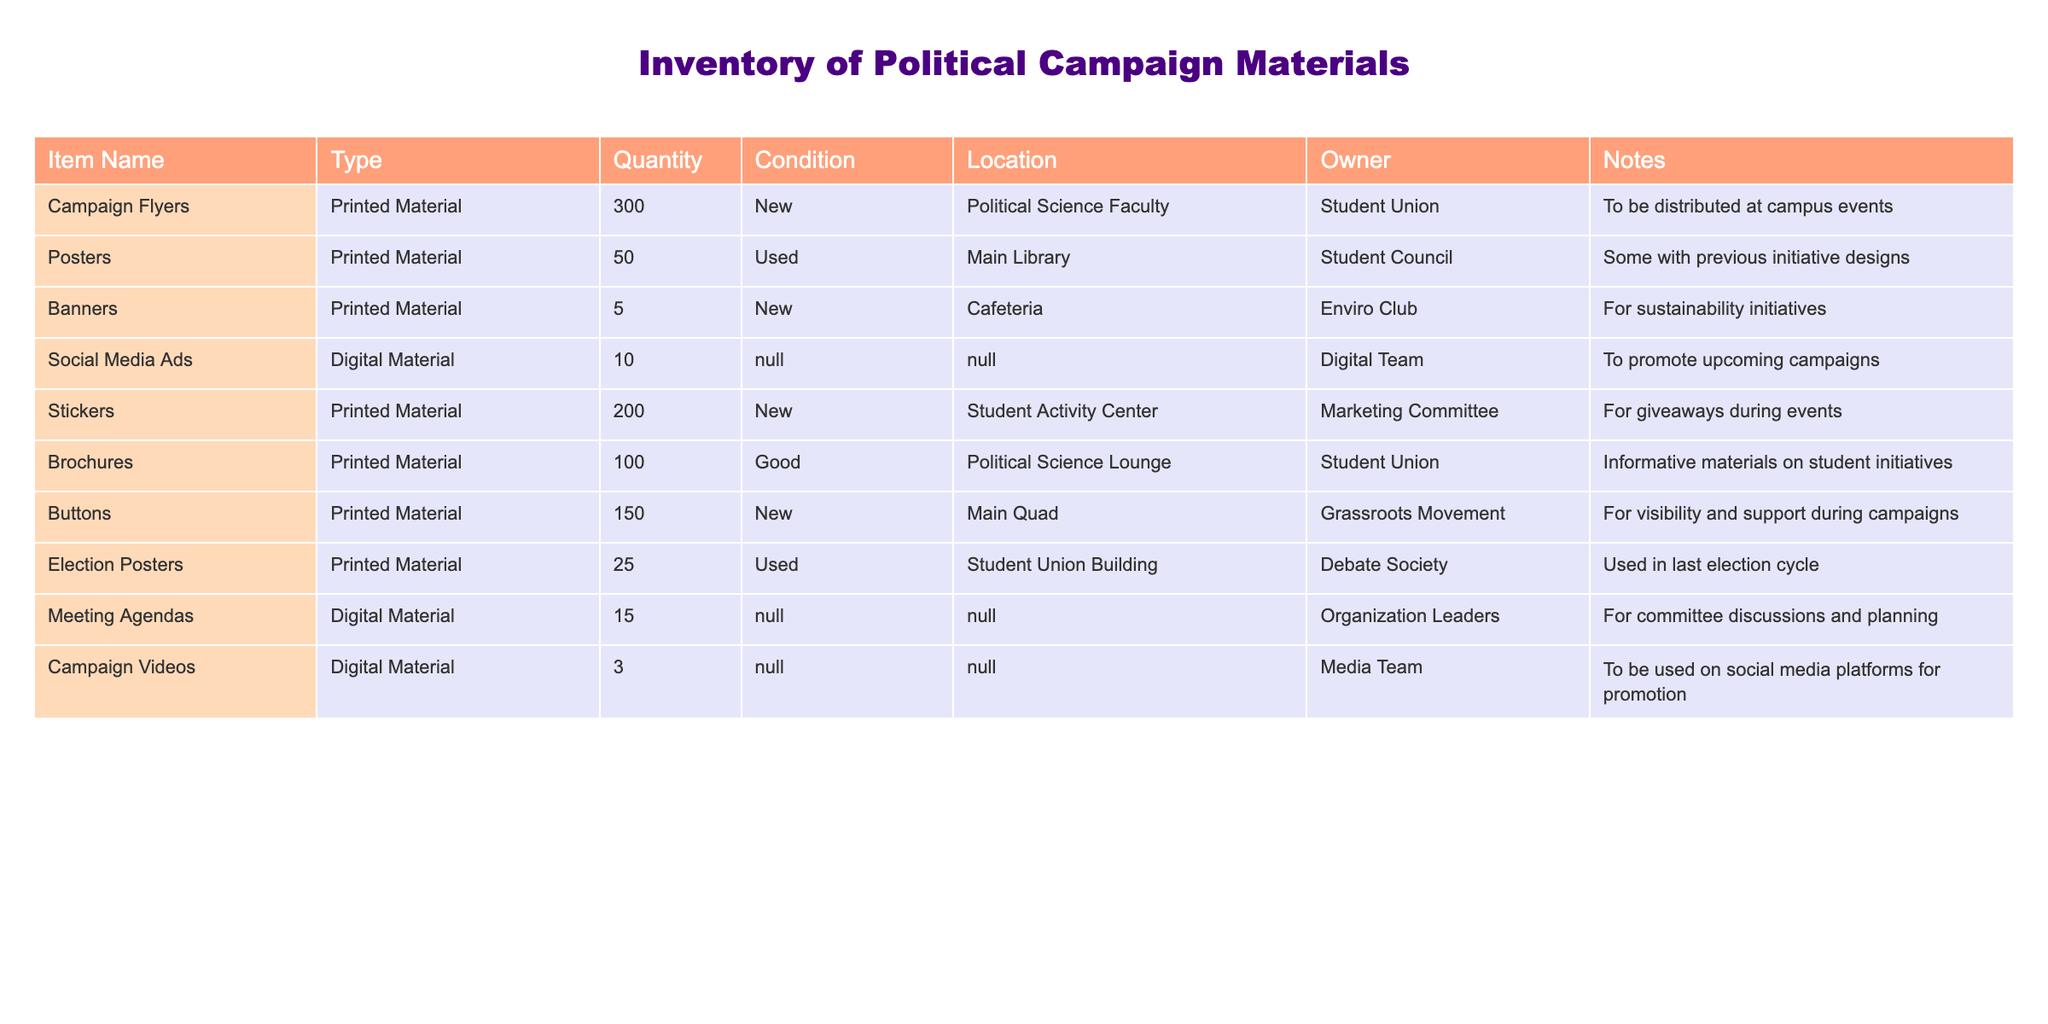What is the total quantity of printed materials in the inventory? To find the total quantity of printed materials, we need to add up the quantities listed for each printed material item: 300 (Campaign Flyers) + 50 (Posters) + 5 (Banners) + 200 (Stickers) + 100 (Brochures) + 150 (Buttons) + 25 (Election Posters) = 930.
Answer: 930 How many items in the inventory are in a 'New' condition? By checking the 'Condition' column, we identify which items are marked as 'New': Campaign Flyers, Banners, Stickers, and Buttons. Counting these gives us a total of 4 items.
Answer: 4 Is there any digital material in the inventory? The table includes Social Media Ads, Meeting Agendas, and Campaign Videos under the 'Digital Material' type. Therefore, the answer is yes.
Answer: Yes Which item has the highest quantity in the inventory? Looking at the 'Quantity' column, Campaign Flyers have the highest quantity with 300. Comparing it to other items: 50 (Posters), 5 (Banners), 200 (Stickers), 100 (Brochures), 150 (Buttons), 25 (Election Posters), and 10 (Social Media Ads), it confirms that Campaign Flyers have the highest quantity.
Answer: Campaign Flyers What is the average quantity of printed materials excluding used items? First, identify the printed materials that are 'New' or 'Good' and sum their quantities: 300 (Campaign Flyers) + 5 (Banners) + 200 (Stickers) + 100 (Brochures) + 150 (Buttons) = 755. There are 5 items considered, so the average is 755/5 = 151.
Answer: 151 How many items in the inventory are stored in the Student Union location? The items located in the Student Union are Campaign Flyers, Brochures, and Election Posters. Counting these gives us a total of 3 items.
Answer: 3 Are there any items in the inventory with less than 10 quantities? Checking the 'Quantity' column reveals that only Banners (5) and Campaign Videos (3) have less than 10 quantities. Thus, the answer is yes as there are items that meet this criteria.
Answer: Yes What is the total number of digital materials in the inventory? The digital materials listed are Social Media Ads (10), Meeting Agendas (15), and Campaign Videos (3). Adding these gives us 10 + 15 + 3 = 28.
Answer: 28 If you want to know how many printed materials are available for sustainability initiatives, what would be the answer? The only printed item specifically mentioned for sustainability initiatives is Banners, with a quantity of 5. Thus, the answer is 5.
Answer: 5 How many items are in 'Used' condition and where are they located? The items in 'Used' condition are Posters (50) and Election Posters (25). They are located in the Main Library and Student Union Building, respectively. Therefore, there are 2 items in 'Used' condition.
Answer: 2 items: Posters in Main Library and Election Posters in Student Union Building 